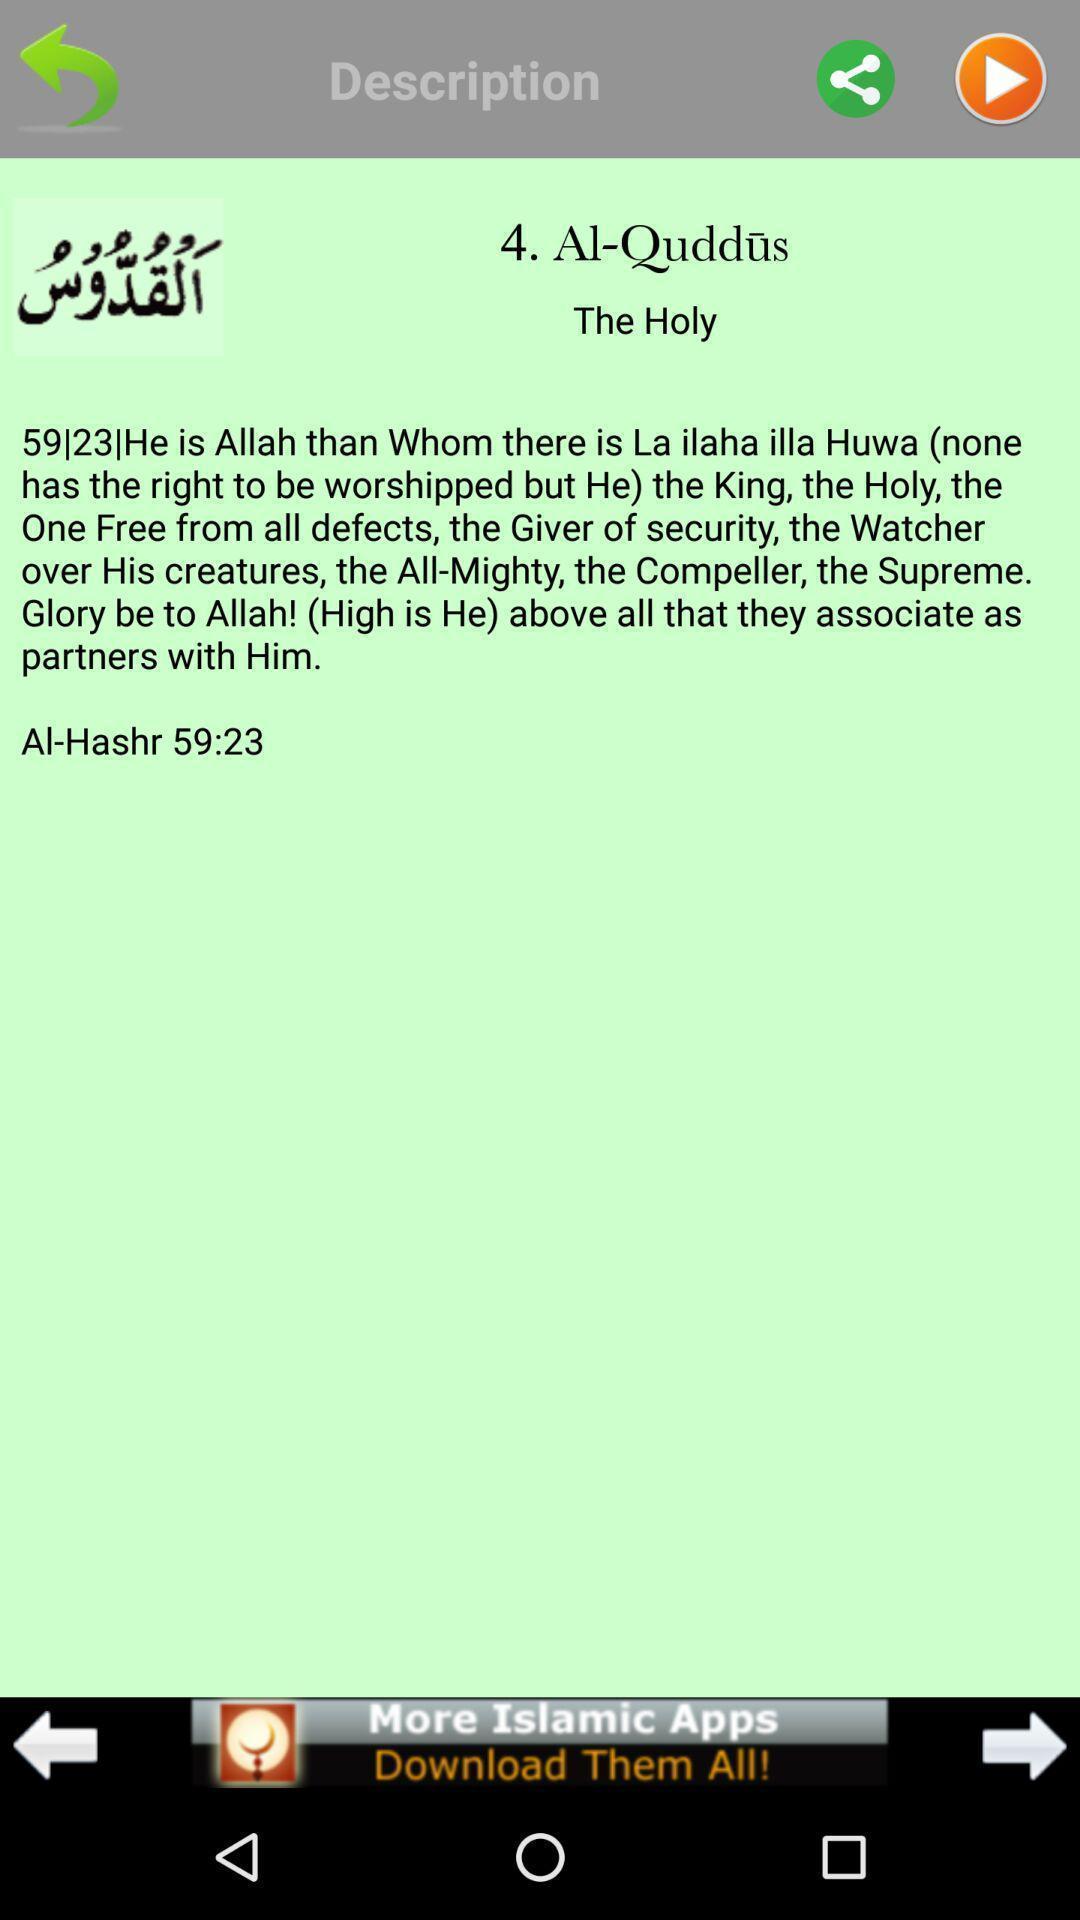Give me a narrative description of this picture. Text on description page of a religious app. 